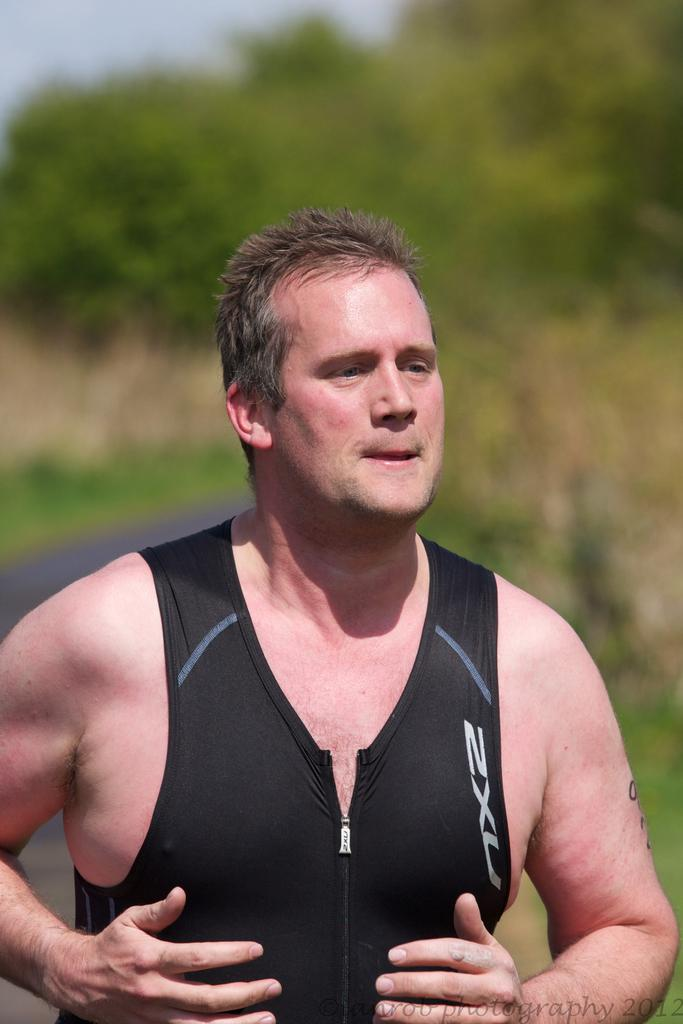Provide a one-sentence caption for the provided image. A man wearing a wet suit vest outside. 